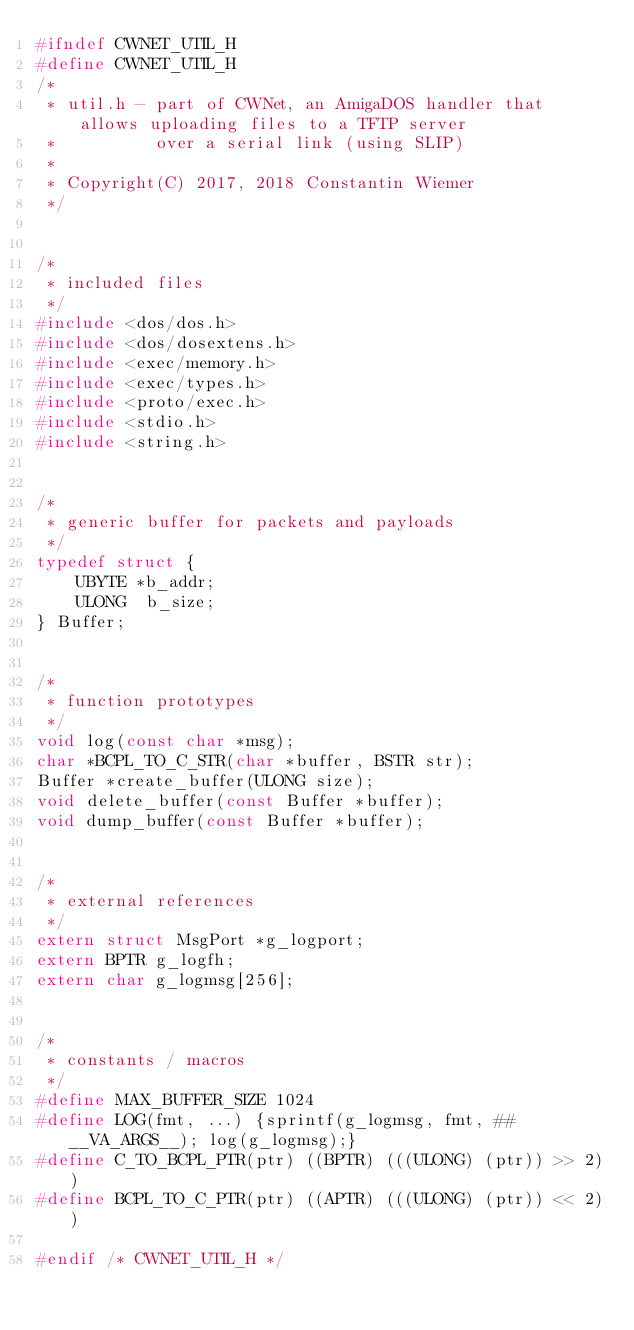<code> <loc_0><loc_0><loc_500><loc_500><_C_>#ifndef CWNET_UTIL_H
#define CWNET_UTIL_H
/*
 * util.h - part of CWNet, an AmigaDOS handler that allows uploading files to a TFTP server
 *          over a serial link (using SLIP)
 *
 * Copyright(C) 2017, 2018 Constantin Wiemer
 */


/*
 * included files
 */
#include <dos/dos.h>
#include <dos/dosextens.h>
#include <exec/memory.h>
#include <exec/types.h>
#include <proto/exec.h>
#include <stdio.h>
#include <string.h>


/*
 * generic buffer for packets and payloads
 */
typedef struct {
    UBYTE *b_addr;
    ULONG  b_size;
} Buffer;


/*
 * function prototypes
 */
void log(const char *msg);
char *BCPL_TO_C_STR(char *buffer, BSTR str);
Buffer *create_buffer(ULONG size);
void delete_buffer(const Buffer *buffer);
void dump_buffer(const Buffer *buffer);


/*
 * external references
 */
extern struct MsgPort *g_logport;
extern BPTR g_logfh;
extern char g_logmsg[256];


/*
 * constants / macros
 */
#define MAX_BUFFER_SIZE 1024
#define LOG(fmt, ...) {sprintf(g_logmsg, fmt, ##__VA_ARGS__); log(g_logmsg);}
#define C_TO_BCPL_PTR(ptr) ((BPTR) (((ULONG) (ptr)) >> 2))
#define BCPL_TO_C_PTR(ptr) ((APTR) (((ULONG) (ptr)) << 2))

#endif /* CWNET_UTIL_H */
</code> 